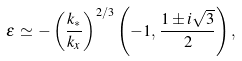<formula> <loc_0><loc_0><loc_500><loc_500>\varepsilon \, \simeq \, - \left ( \frac { k _ { * } } { k _ { x } } \right ) ^ { 2 / 3 } \left ( - 1 , \, \frac { 1 \pm i \sqrt { 3 } } { 2 } \right ) ,</formula> 